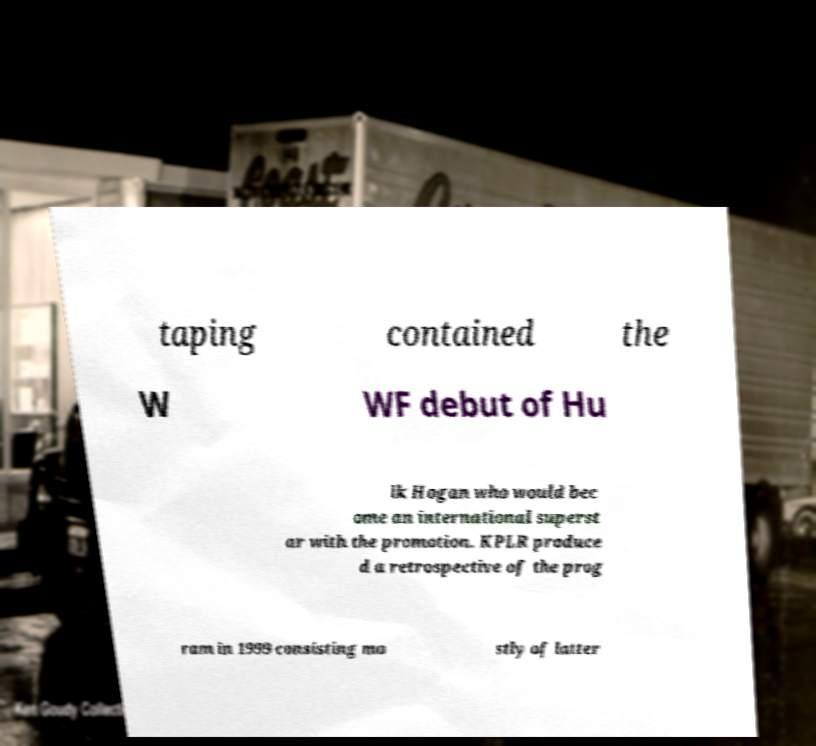What messages or text are displayed in this image? I need them in a readable, typed format. taping contained the W WF debut of Hu lk Hogan who would bec ome an international superst ar with the promotion. KPLR produce d a retrospective of the prog ram in 1999 consisting mo stly of latter 